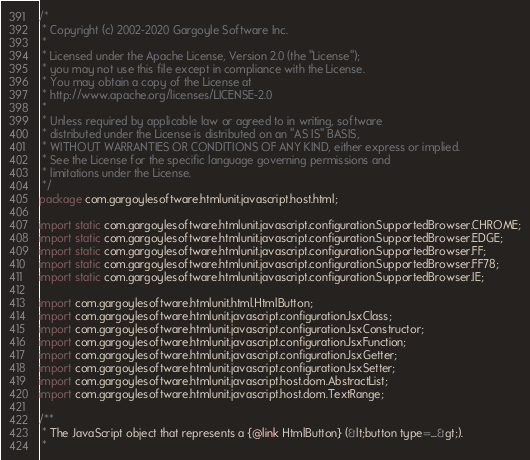<code> <loc_0><loc_0><loc_500><loc_500><_Java_>/*
 * Copyright (c) 2002-2020 Gargoyle Software Inc.
 *
 * Licensed under the Apache License, Version 2.0 (the "License");
 * you may not use this file except in compliance with the License.
 * You may obtain a copy of the License at
 * http://www.apache.org/licenses/LICENSE-2.0
 *
 * Unless required by applicable law or agreed to in writing, software
 * distributed under the License is distributed on an "AS IS" BASIS,
 * WITHOUT WARRANTIES OR CONDITIONS OF ANY KIND, either express or implied.
 * See the License for the specific language governing permissions and
 * limitations under the License.
 */
package com.gargoylesoftware.htmlunit.javascript.host.html;

import static com.gargoylesoftware.htmlunit.javascript.configuration.SupportedBrowser.CHROME;
import static com.gargoylesoftware.htmlunit.javascript.configuration.SupportedBrowser.EDGE;
import static com.gargoylesoftware.htmlunit.javascript.configuration.SupportedBrowser.FF;
import static com.gargoylesoftware.htmlunit.javascript.configuration.SupportedBrowser.FF78;
import static com.gargoylesoftware.htmlunit.javascript.configuration.SupportedBrowser.IE;

import com.gargoylesoftware.htmlunit.html.HtmlButton;
import com.gargoylesoftware.htmlunit.javascript.configuration.JsxClass;
import com.gargoylesoftware.htmlunit.javascript.configuration.JsxConstructor;
import com.gargoylesoftware.htmlunit.javascript.configuration.JsxFunction;
import com.gargoylesoftware.htmlunit.javascript.configuration.JsxGetter;
import com.gargoylesoftware.htmlunit.javascript.configuration.JsxSetter;
import com.gargoylesoftware.htmlunit.javascript.host.dom.AbstractList;
import com.gargoylesoftware.htmlunit.javascript.host.dom.TextRange;

/**
 * The JavaScript object that represents a {@link HtmlButton} (&lt;button type=...&gt;).
 *</code> 